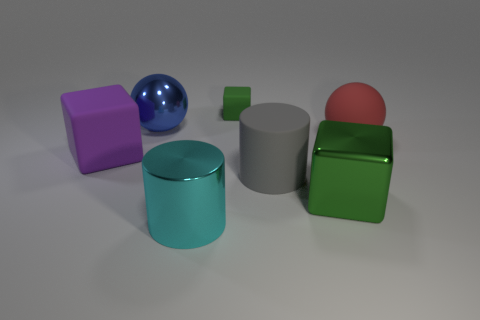Subtract all cyan cylinders. Subtract all purple spheres. How many cylinders are left? 1 Add 1 tiny green metal cylinders. How many objects exist? 8 Subtract all spheres. How many objects are left? 5 Add 1 cyan matte cylinders. How many cyan matte cylinders exist? 1 Subtract 1 green cubes. How many objects are left? 6 Subtract all purple shiny things. Subtract all cyan cylinders. How many objects are left? 6 Add 2 large objects. How many large objects are left? 8 